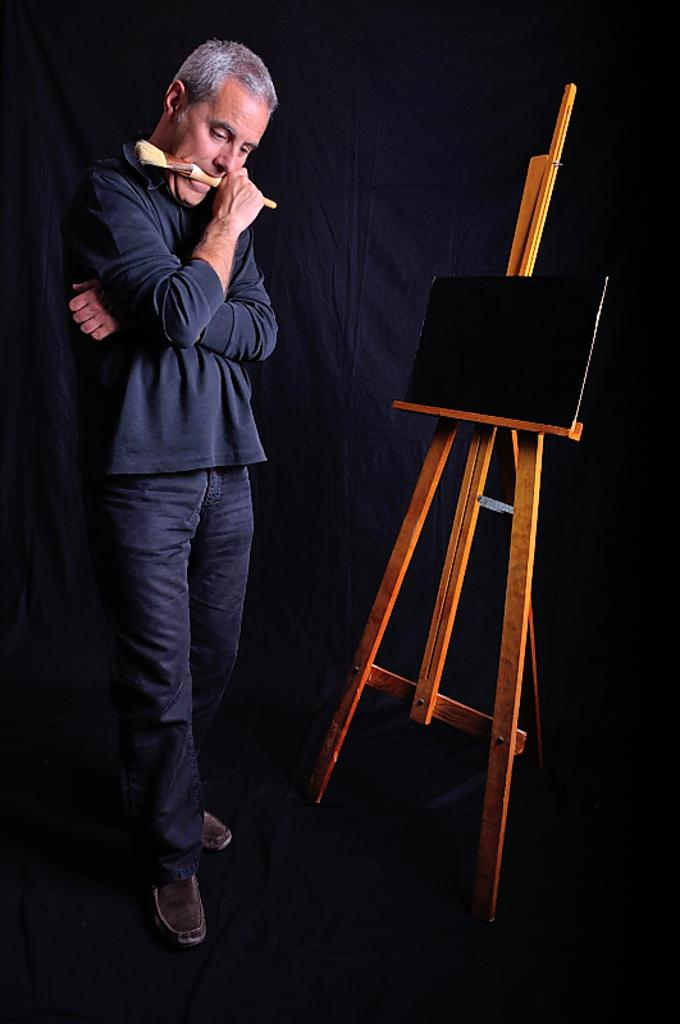Who is present in the image? There is a man in the image. What is the man holding in the image? The man is holding a brush. What can be seen on the wooden stand in the image? There is a board on the wooden stand in the image. What is the color of the background in the image? The background of the image is dark. What type of cap is the man wearing in the image? There is no cap visible in the image; the man is not wearing one. 